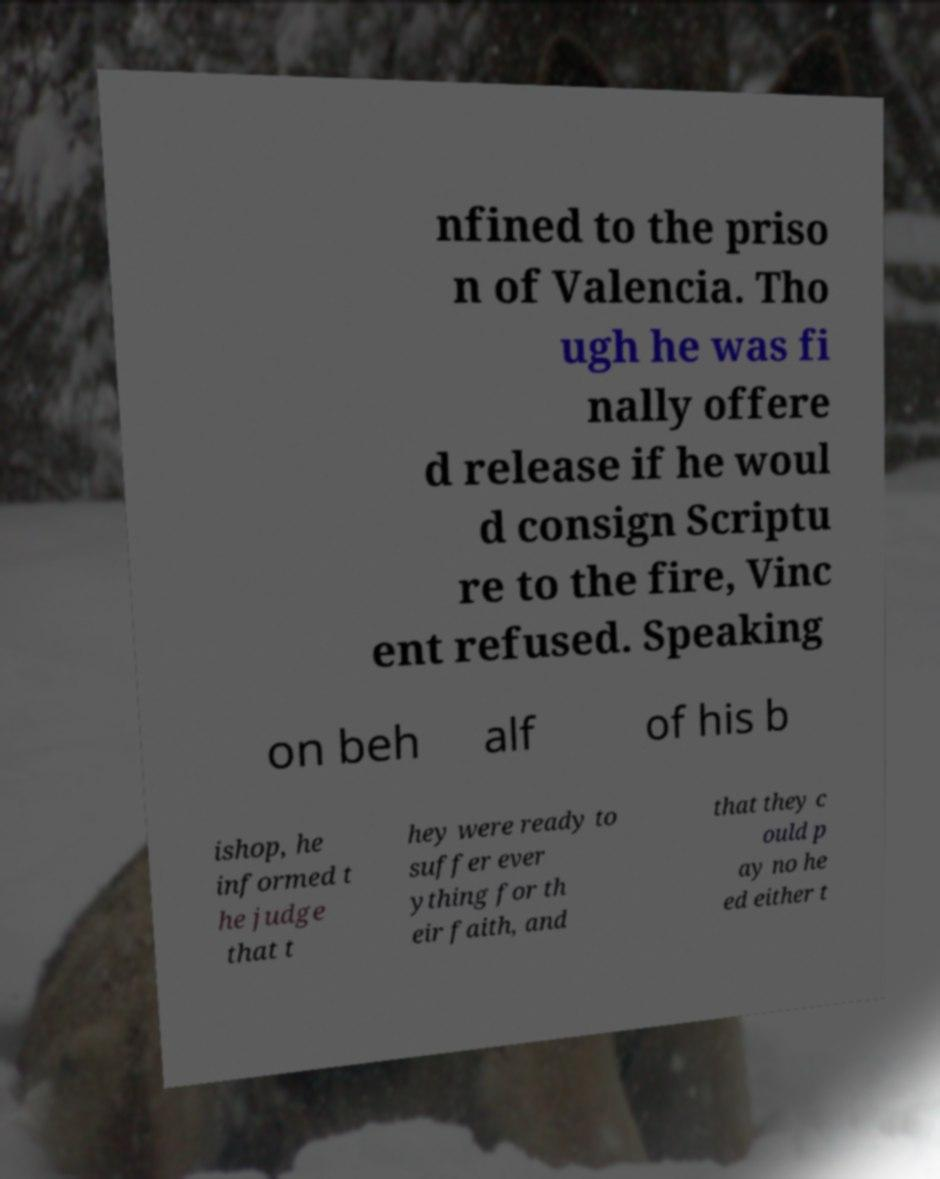Please identify and transcribe the text found in this image. nfined to the priso n of Valencia. Tho ugh he was fi nally offere d release if he woul d consign Scriptu re to the fire, Vinc ent refused. Speaking on beh alf of his b ishop, he informed t he judge that t hey were ready to suffer ever ything for th eir faith, and that they c ould p ay no he ed either t 